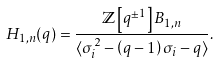<formula> <loc_0><loc_0><loc_500><loc_500>H _ { 1 , n } ( q ) = \frac { { \mathbb { Z } } \left [ q ^ { \pm 1 } \right ] B _ { 1 , n } } { \langle \sigma _ { i } ^ { 2 } - \left ( q - 1 \right ) \sigma _ { i } - q \rangle } .</formula> 